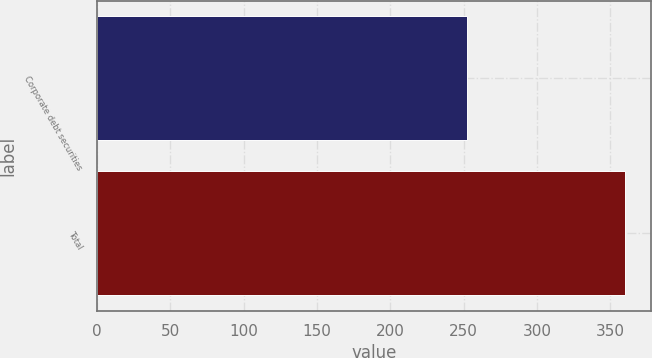<chart> <loc_0><loc_0><loc_500><loc_500><bar_chart><fcel>Corporate debt securities<fcel>Total<nl><fcel>252<fcel>360<nl></chart> 